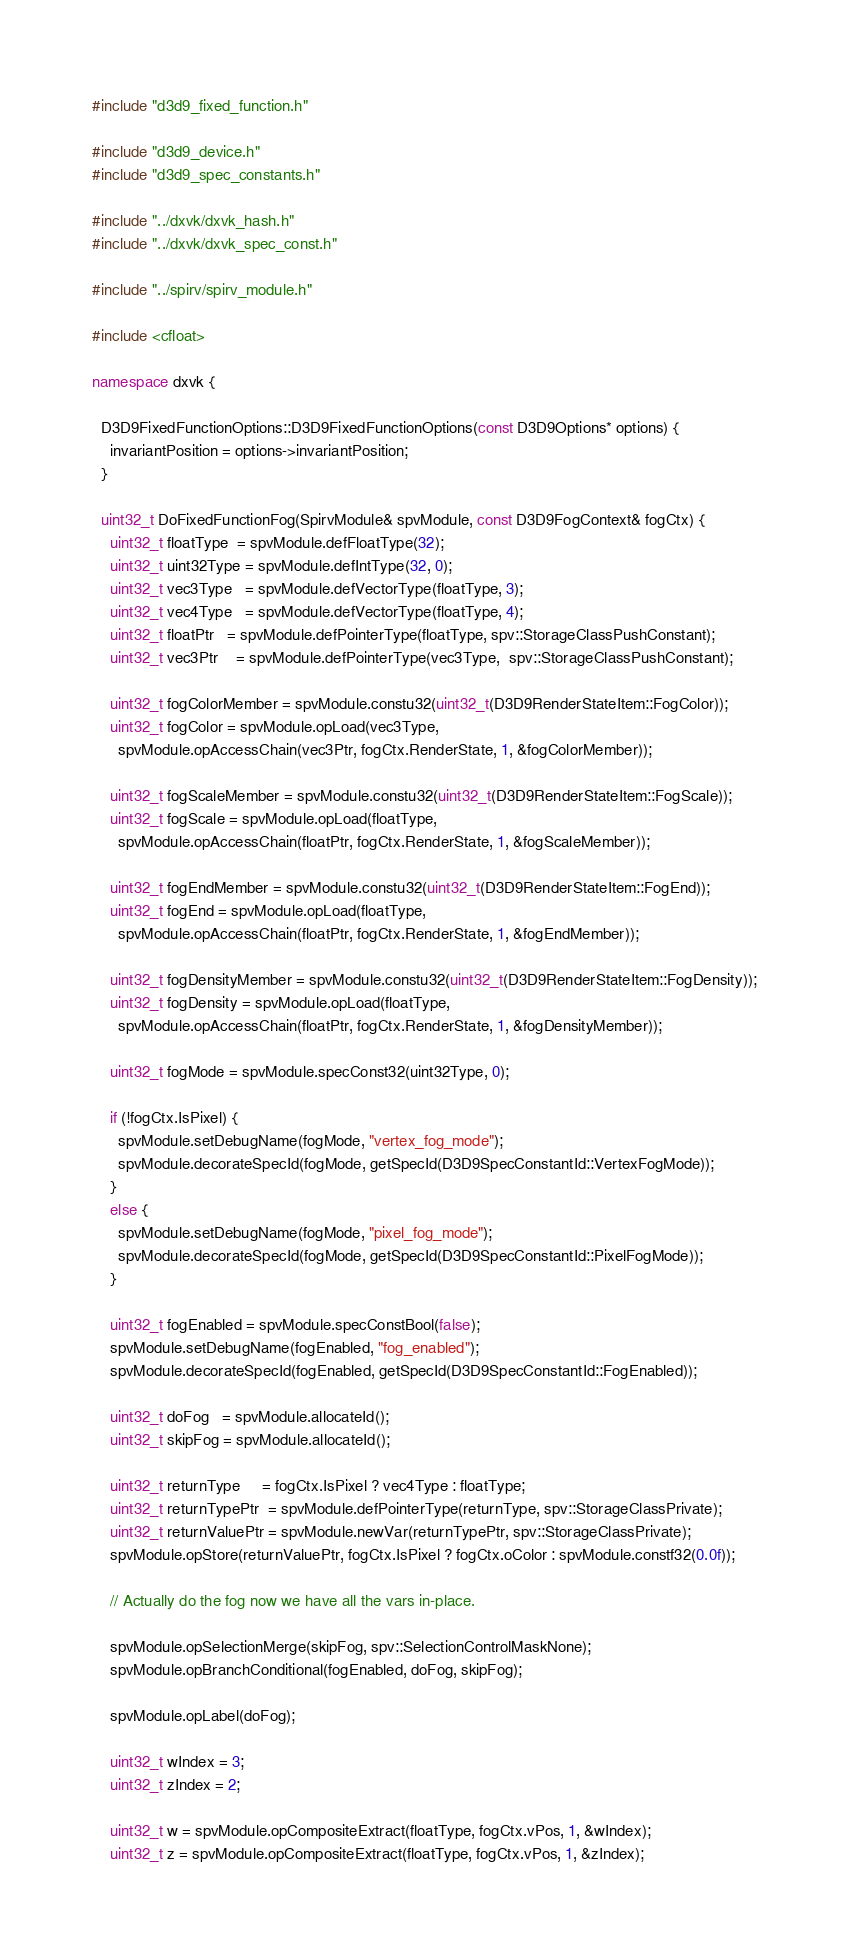<code> <loc_0><loc_0><loc_500><loc_500><_C++_>#include "d3d9_fixed_function.h"

#include "d3d9_device.h"
#include "d3d9_spec_constants.h"

#include "../dxvk/dxvk_hash.h"
#include "../dxvk/dxvk_spec_const.h"

#include "../spirv/spirv_module.h"

#include <cfloat>

namespace dxvk {

  D3D9FixedFunctionOptions::D3D9FixedFunctionOptions(const D3D9Options* options) {
    invariantPosition = options->invariantPosition;
  }

  uint32_t DoFixedFunctionFog(SpirvModule& spvModule, const D3D9FogContext& fogCtx) {
    uint32_t floatType  = spvModule.defFloatType(32);
    uint32_t uint32Type = spvModule.defIntType(32, 0);
    uint32_t vec3Type   = spvModule.defVectorType(floatType, 3);
    uint32_t vec4Type   = spvModule.defVectorType(floatType, 4);
    uint32_t floatPtr   = spvModule.defPointerType(floatType, spv::StorageClassPushConstant);
    uint32_t vec3Ptr    = spvModule.defPointerType(vec3Type,  spv::StorageClassPushConstant);

    uint32_t fogColorMember = spvModule.constu32(uint32_t(D3D9RenderStateItem::FogColor));
    uint32_t fogColor = spvModule.opLoad(vec3Type,
      spvModule.opAccessChain(vec3Ptr, fogCtx.RenderState, 1, &fogColorMember));

    uint32_t fogScaleMember = spvModule.constu32(uint32_t(D3D9RenderStateItem::FogScale));
    uint32_t fogScale = spvModule.opLoad(floatType,
      spvModule.opAccessChain(floatPtr, fogCtx.RenderState, 1, &fogScaleMember));

    uint32_t fogEndMember = spvModule.constu32(uint32_t(D3D9RenderStateItem::FogEnd));
    uint32_t fogEnd = spvModule.opLoad(floatType,
      spvModule.opAccessChain(floatPtr, fogCtx.RenderState, 1, &fogEndMember));

    uint32_t fogDensityMember = spvModule.constu32(uint32_t(D3D9RenderStateItem::FogDensity));
    uint32_t fogDensity = spvModule.opLoad(floatType,
      spvModule.opAccessChain(floatPtr, fogCtx.RenderState, 1, &fogDensityMember));

    uint32_t fogMode = spvModule.specConst32(uint32Type, 0);

    if (!fogCtx.IsPixel) {
      spvModule.setDebugName(fogMode, "vertex_fog_mode");
      spvModule.decorateSpecId(fogMode, getSpecId(D3D9SpecConstantId::VertexFogMode));
    }
    else {
      spvModule.setDebugName(fogMode, "pixel_fog_mode");
      spvModule.decorateSpecId(fogMode, getSpecId(D3D9SpecConstantId::PixelFogMode));
    }

    uint32_t fogEnabled = spvModule.specConstBool(false);
    spvModule.setDebugName(fogEnabled, "fog_enabled");
    spvModule.decorateSpecId(fogEnabled, getSpecId(D3D9SpecConstantId::FogEnabled));

    uint32_t doFog   = spvModule.allocateId();
    uint32_t skipFog = spvModule.allocateId();

    uint32_t returnType     = fogCtx.IsPixel ? vec4Type : floatType;
    uint32_t returnTypePtr  = spvModule.defPointerType(returnType, spv::StorageClassPrivate);
    uint32_t returnValuePtr = spvModule.newVar(returnTypePtr, spv::StorageClassPrivate);
    spvModule.opStore(returnValuePtr, fogCtx.IsPixel ? fogCtx.oColor : spvModule.constf32(0.0f));

    // Actually do the fog now we have all the vars in-place.

    spvModule.opSelectionMerge(skipFog, spv::SelectionControlMaskNone);
    spvModule.opBranchConditional(fogEnabled, doFog, skipFog);

    spvModule.opLabel(doFog);

    uint32_t wIndex = 3;
    uint32_t zIndex = 2;

    uint32_t w = spvModule.opCompositeExtract(floatType, fogCtx.vPos, 1, &wIndex);
    uint32_t z = spvModule.opCompositeExtract(floatType, fogCtx.vPos, 1, &zIndex);
</code> 